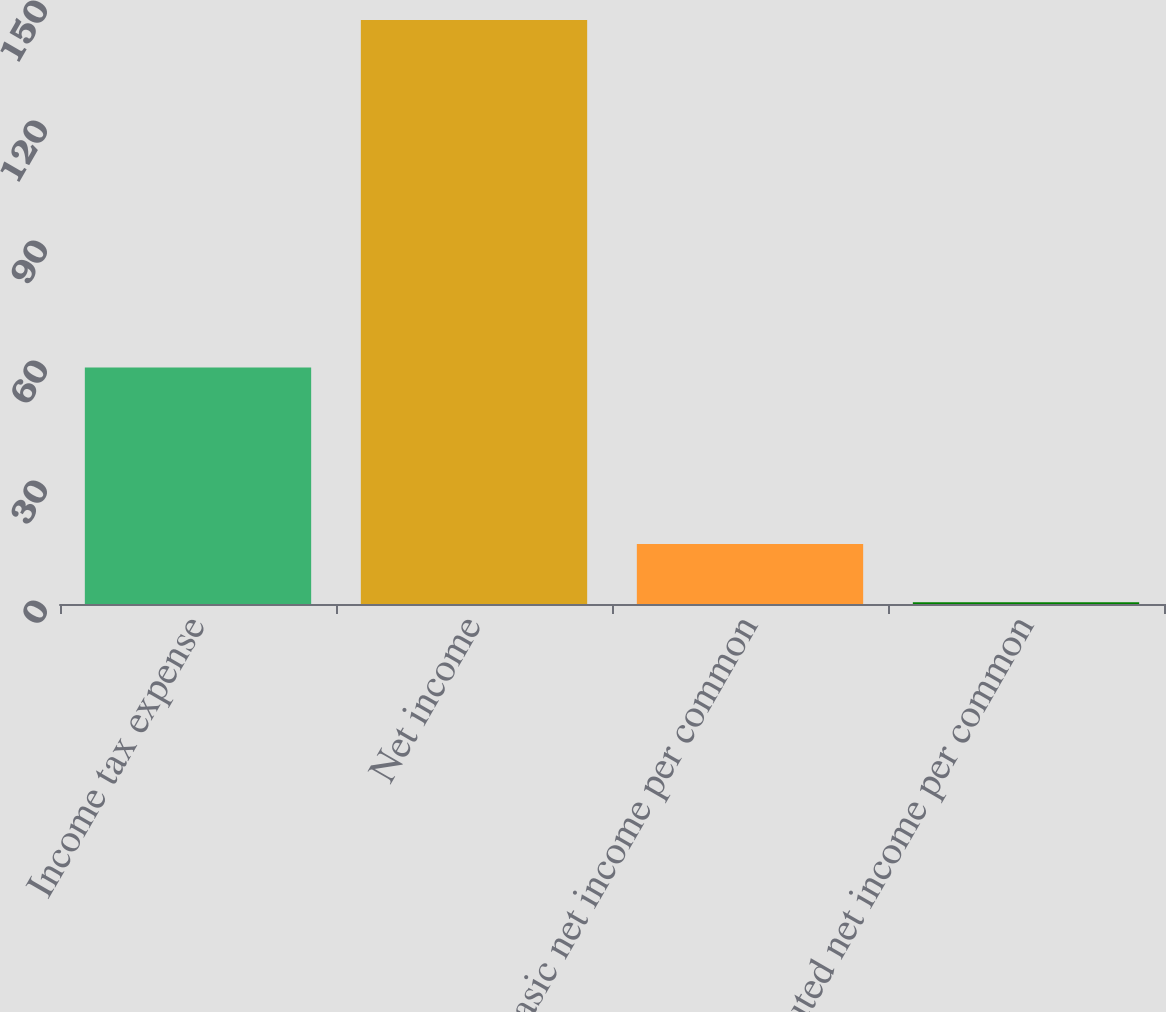Convert chart. <chart><loc_0><loc_0><loc_500><loc_500><bar_chart><fcel>Income tax expense<fcel>Net income<fcel>Basic net income per common<fcel>Diluted net income per common<nl><fcel>59.1<fcel>146<fcel>14.98<fcel>0.42<nl></chart> 